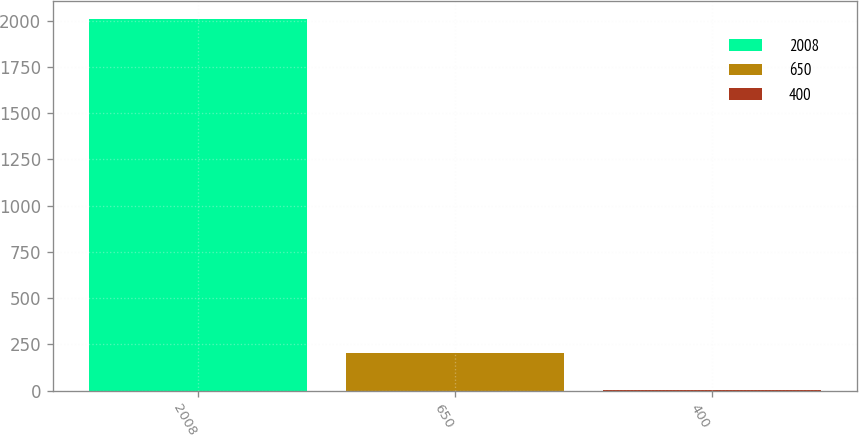Convert chart to OTSL. <chart><loc_0><loc_0><loc_500><loc_500><bar_chart><fcel>2008<fcel>650<fcel>400<nl><fcel>2007<fcel>205.11<fcel>4.9<nl></chart> 